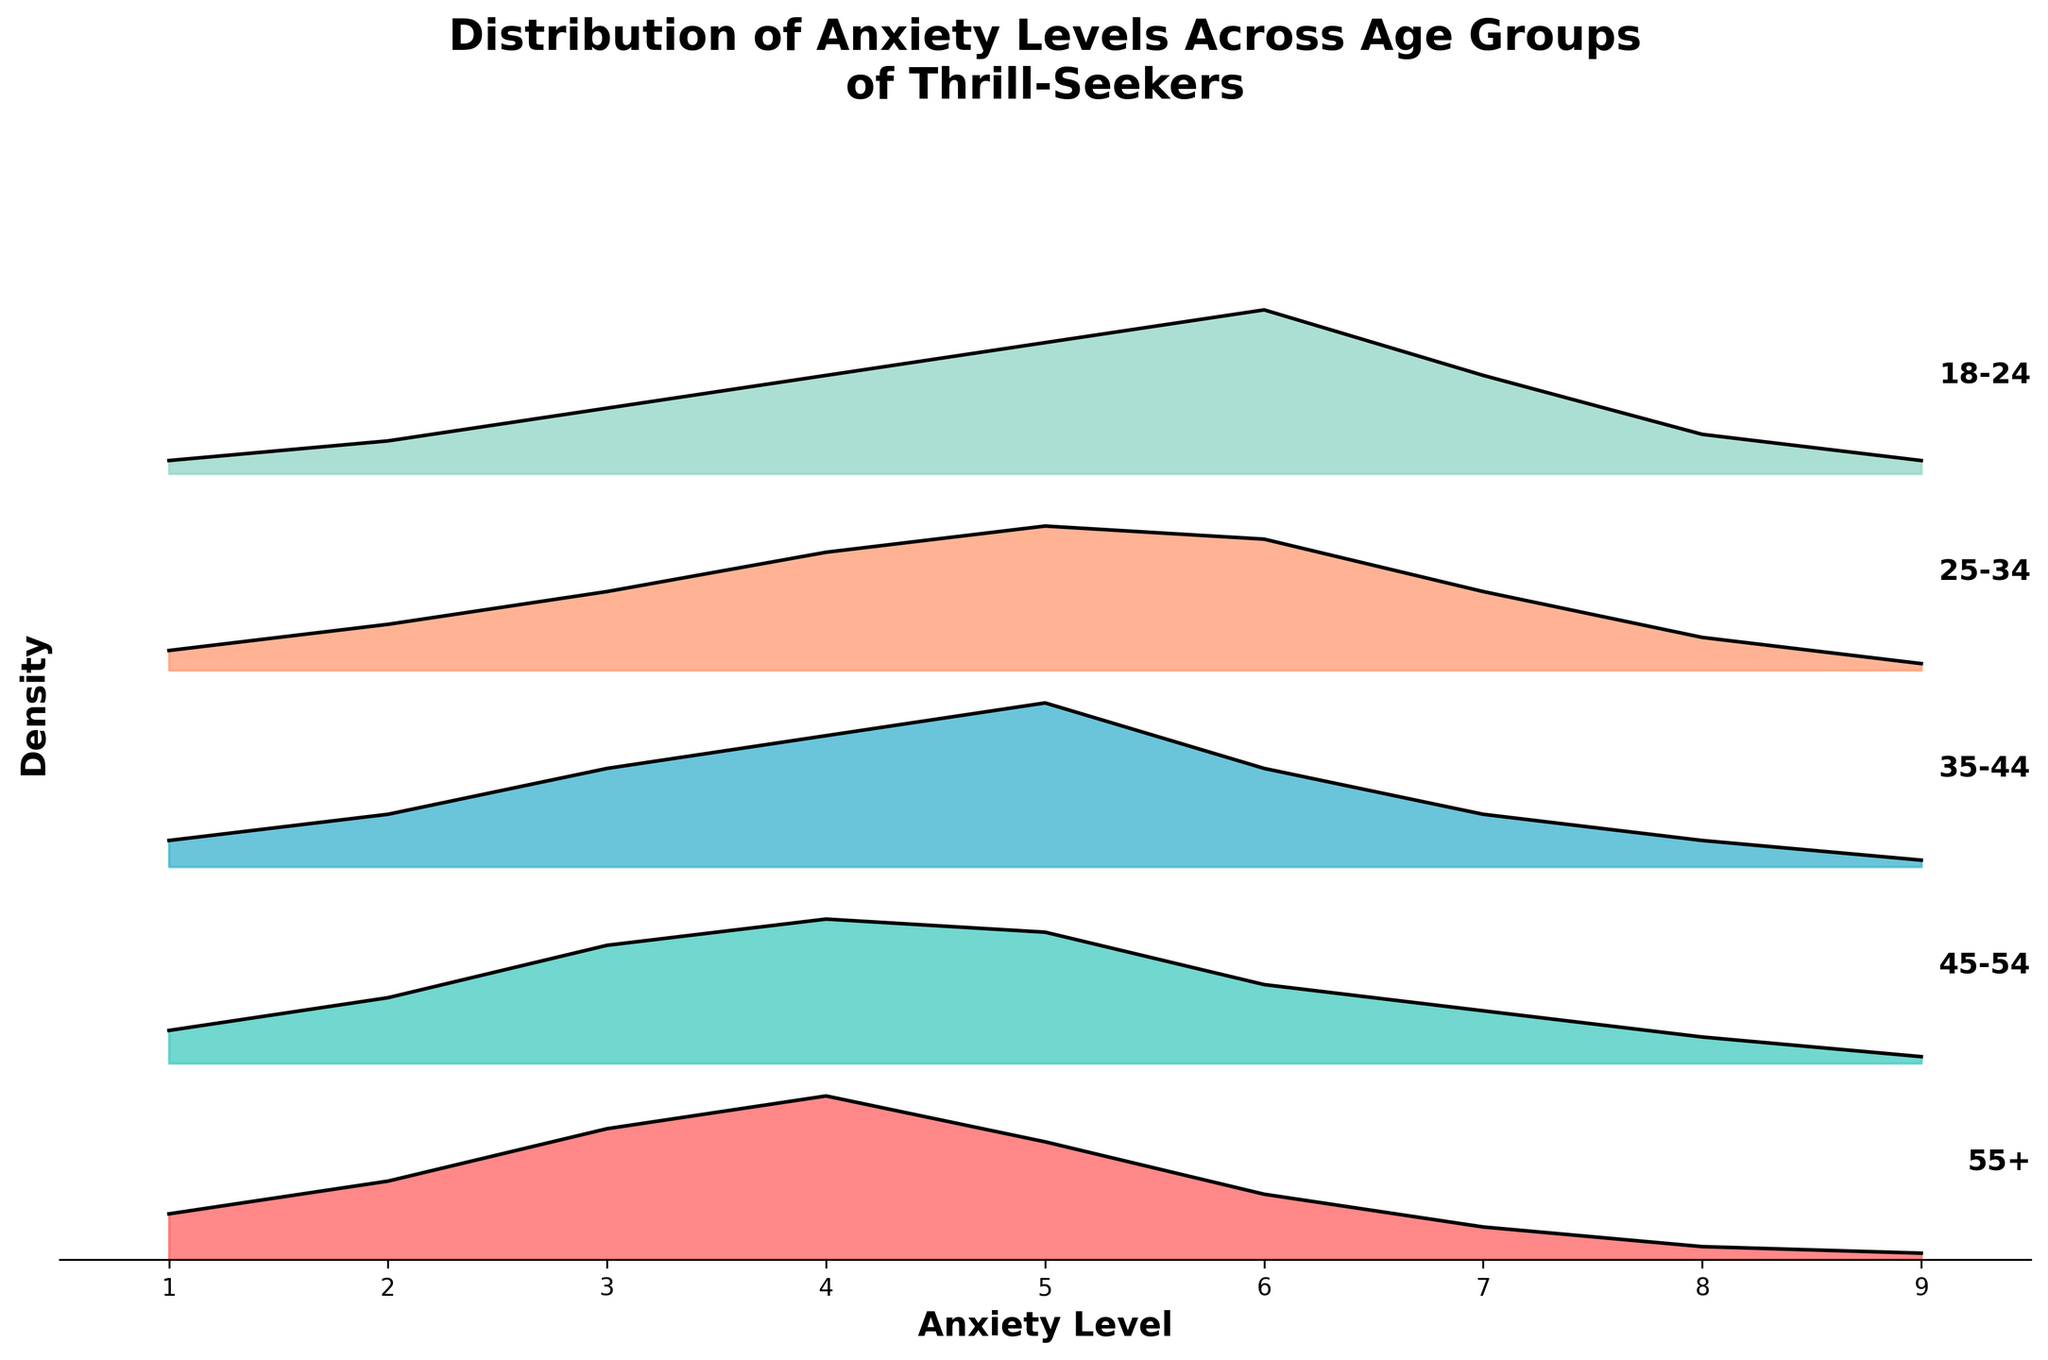What is the title of the plot? The title is located at the top of the plot, and it gives an overview of what the plot represents.
Answer: Distribution of Anxiety Levels Across Age Groups of Thrill-Seekers What is the x-axis label? The x-axis label is shown at the bottom of the plot, indicating what the horizontal axis represents.
Answer: Anxiety Level How many distinct age groups are represented in the plot? The different colored ridgelines and the labels at the right end of each ridgeline indicate the number of age groups.
Answer: 5 Which age group shows the highest density for anxiety level 5? By observing the peaks along the x-axis at anxiety level 5, you can determine which age group has the highest density.
Answer: 35-44 What is the range of anxiety levels in this plot? The x-axis range determines the minimum and maximum anxiety levels represented.
Answer: 1 to 9 Which age group has the lowest maximum anxiety level density? By comparing the tallest peak of each ridgeline, we can identify which age group has the lowest peak.
Answer: 45-54 How does the density of anxiety level 4 differ between the 18-24 and 55+ age groups? Compare the heights of the ridgelines at anxiety level 4 for both age groups to see how they differ.
Answer: Higher in 55+ What general trend do you observe about anxiety levels as age increases? By examining the density of anxiety levels across different age groups, we can determine any observable patterns or trends.
Answer: Shifts higher then decreases with age For which age group is anxiety level 6 more predominant than anxiety level 5? Compare the heights at anxiety levels 5 and 6 for each age group to find where level 6 is more prominent.
Answer: 18-24 What is the most common anxiety level for the 25-34 age group? How do you determine it? Identify the peak of the ridgeline for the 25-34 age group, as it indicates the most frequent anxiety level.
Answer: 5 